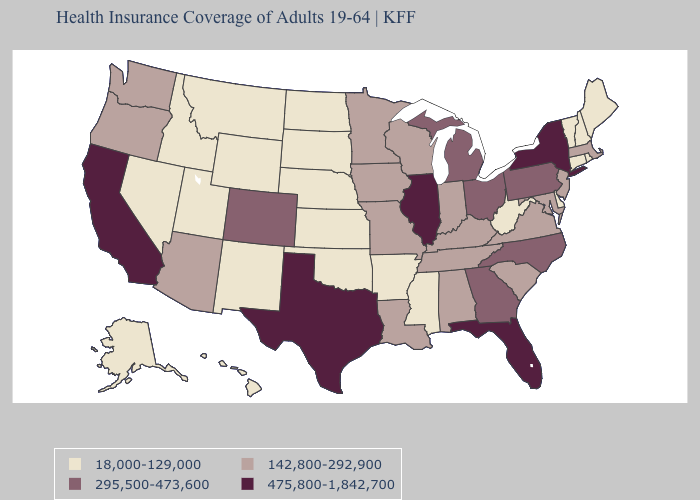Does North Dakota have the same value as California?
Short answer required. No. Name the states that have a value in the range 475,800-1,842,700?
Write a very short answer. California, Florida, Illinois, New York, Texas. What is the value of Delaware?
Be succinct. 18,000-129,000. What is the lowest value in states that border Nebraska?
Keep it brief. 18,000-129,000. Name the states that have a value in the range 18,000-129,000?
Give a very brief answer. Alaska, Arkansas, Connecticut, Delaware, Hawaii, Idaho, Kansas, Maine, Mississippi, Montana, Nebraska, Nevada, New Hampshire, New Mexico, North Dakota, Oklahoma, Rhode Island, South Dakota, Utah, Vermont, West Virginia, Wyoming. What is the lowest value in the USA?
Answer briefly. 18,000-129,000. Does the map have missing data?
Short answer required. No. Which states have the lowest value in the MidWest?
Keep it brief. Kansas, Nebraska, North Dakota, South Dakota. Name the states that have a value in the range 295,500-473,600?
Answer briefly. Colorado, Georgia, Michigan, North Carolina, Ohio, Pennsylvania. Name the states that have a value in the range 475,800-1,842,700?
Give a very brief answer. California, Florida, Illinois, New York, Texas. Among the states that border Florida , does Alabama have the lowest value?
Concise answer only. Yes. What is the lowest value in the USA?
Answer briefly. 18,000-129,000. What is the value of Iowa?
Write a very short answer. 142,800-292,900. What is the value of Connecticut?
Be succinct. 18,000-129,000. Name the states that have a value in the range 475,800-1,842,700?
Be succinct. California, Florida, Illinois, New York, Texas. 